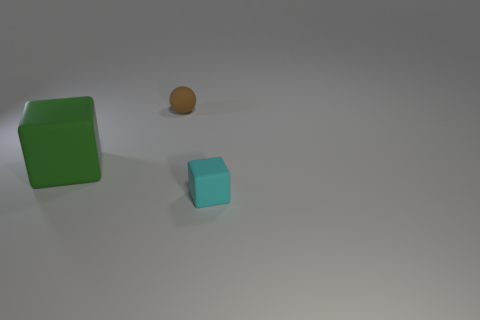Add 3 small purple metallic objects. How many objects exist? 6 Subtract all cubes. How many objects are left? 1 Subtract all tiny brown spheres. Subtract all large purple metallic cubes. How many objects are left? 2 Add 3 tiny rubber things. How many tiny rubber things are left? 5 Add 2 cyan matte objects. How many cyan matte objects exist? 3 Subtract 0 blue cubes. How many objects are left? 3 